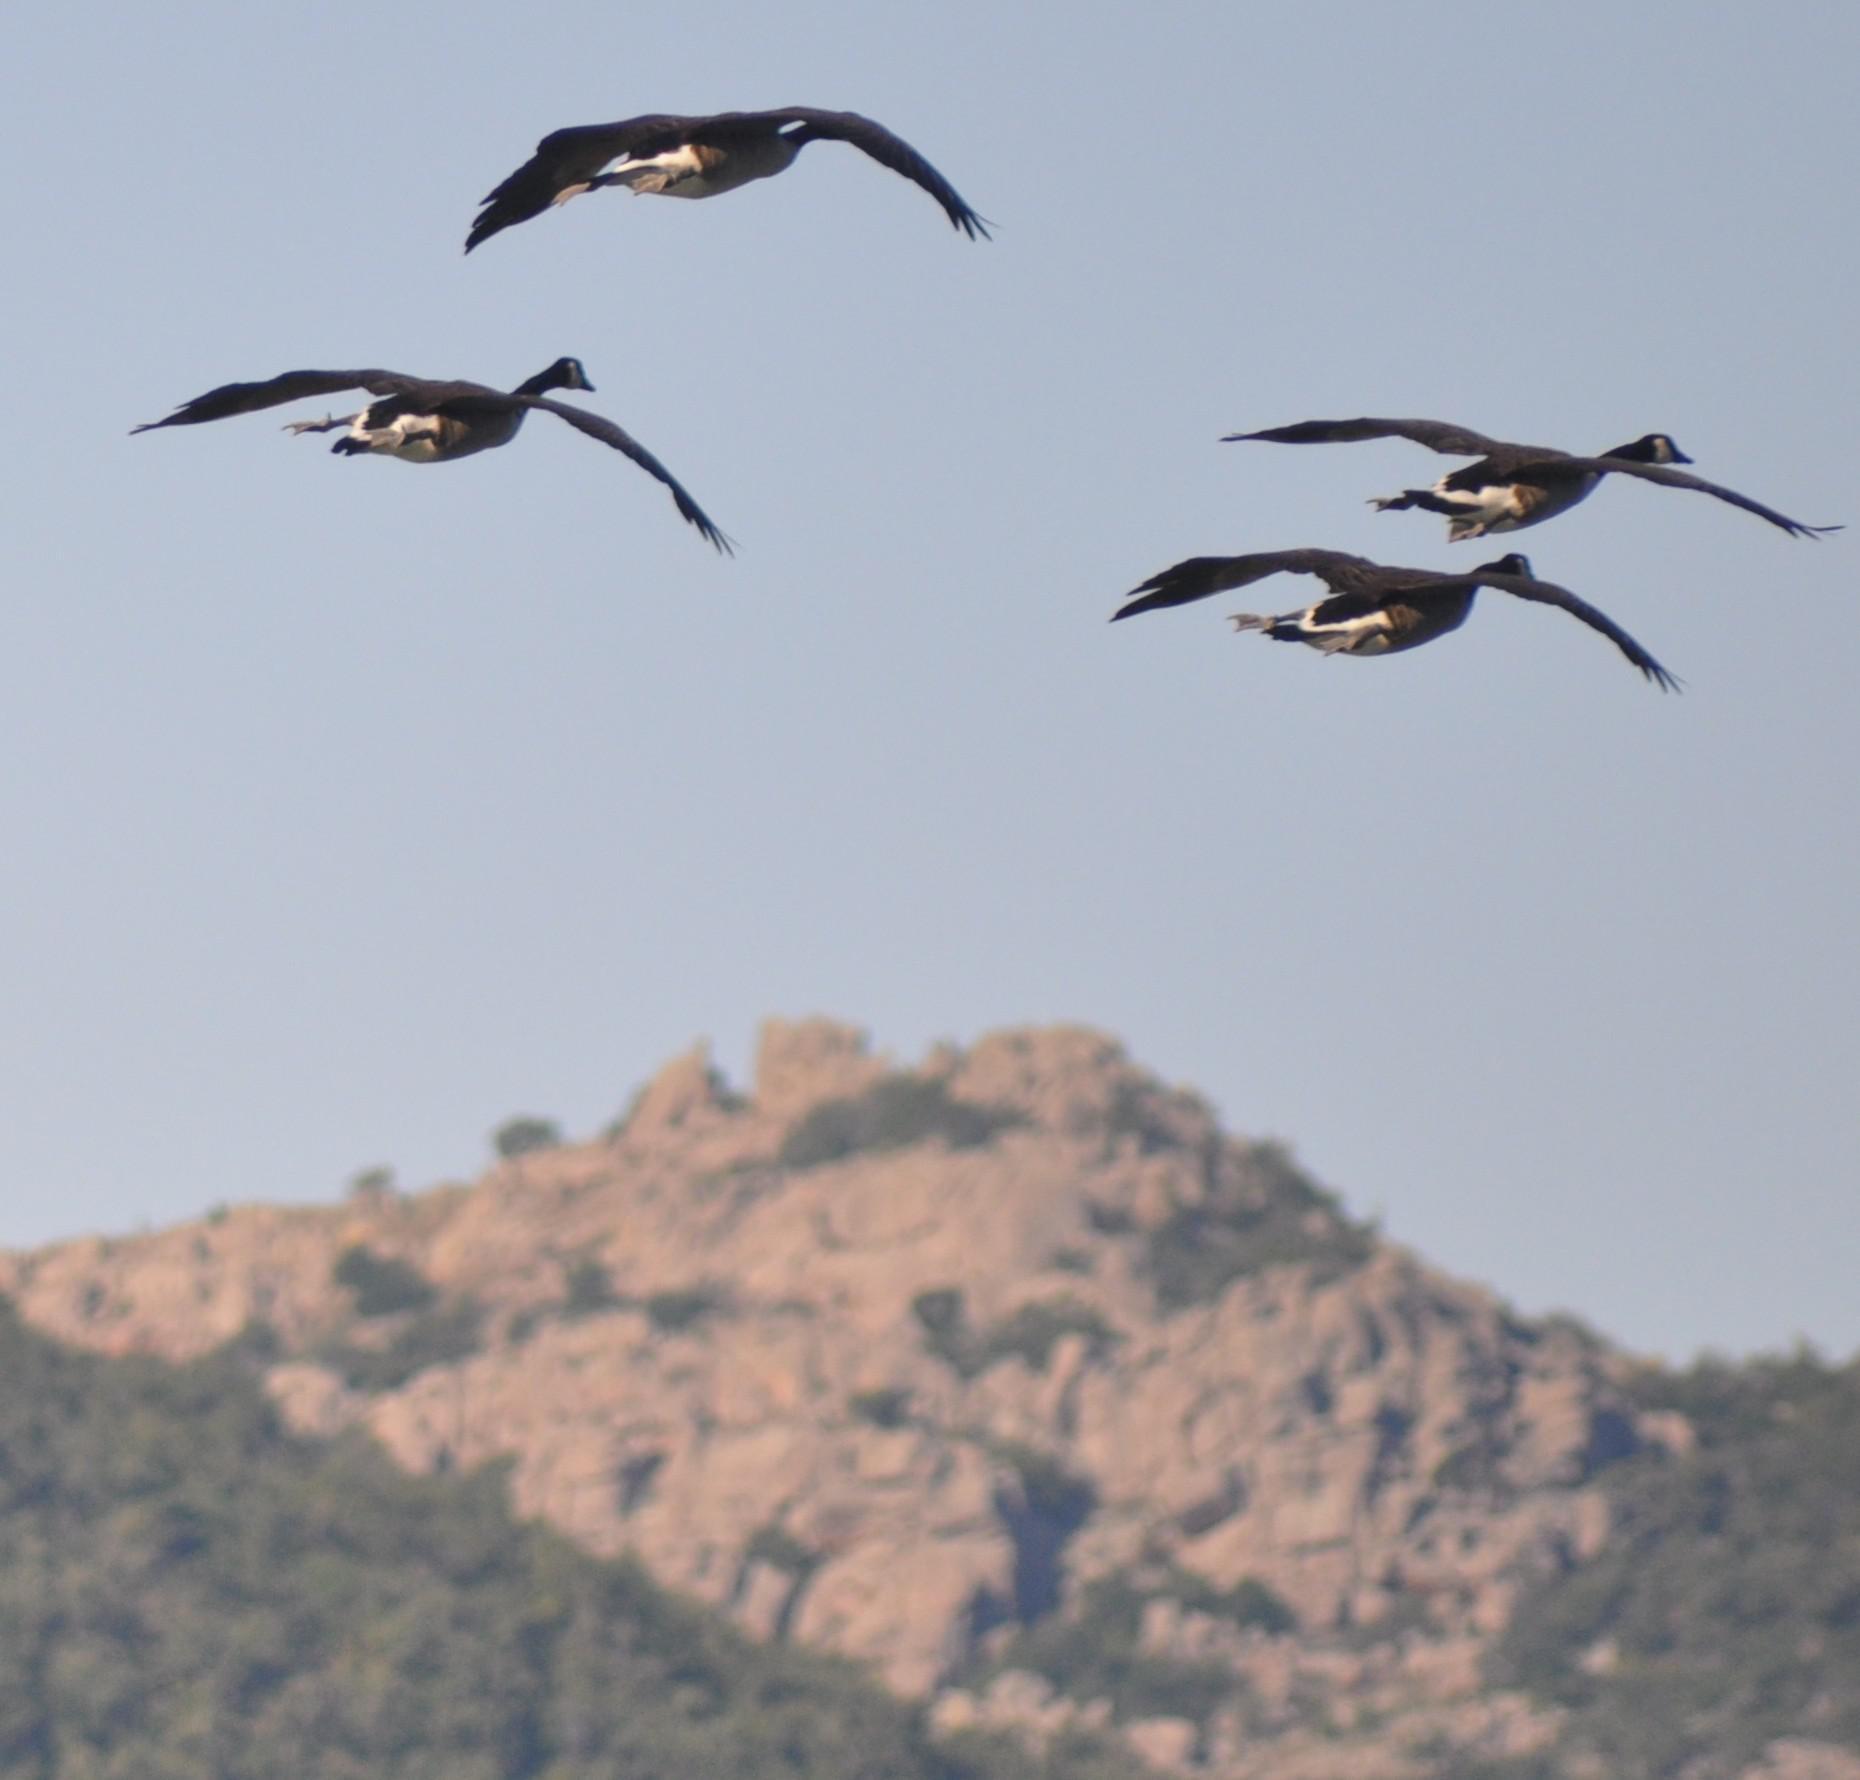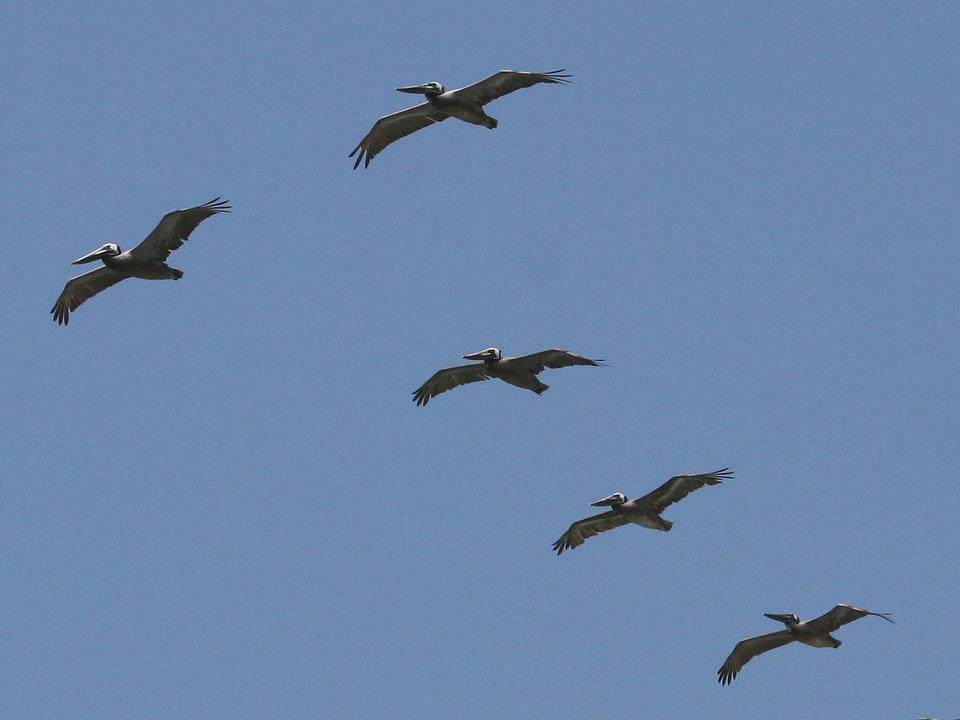The first image is the image on the left, the second image is the image on the right. Evaluate the accuracy of this statement regarding the images: "The right image contains exactly two birds flying in the sky.". Is it true? Answer yes or no. No. The first image is the image on the left, the second image is the image on the right. For the images displayed, is the sentence "All pelicans are in flight, left and right images contain the same number of pelican-type birds, and no single image contains more than two pelicans." factually correct? Answer yes or no. No. 